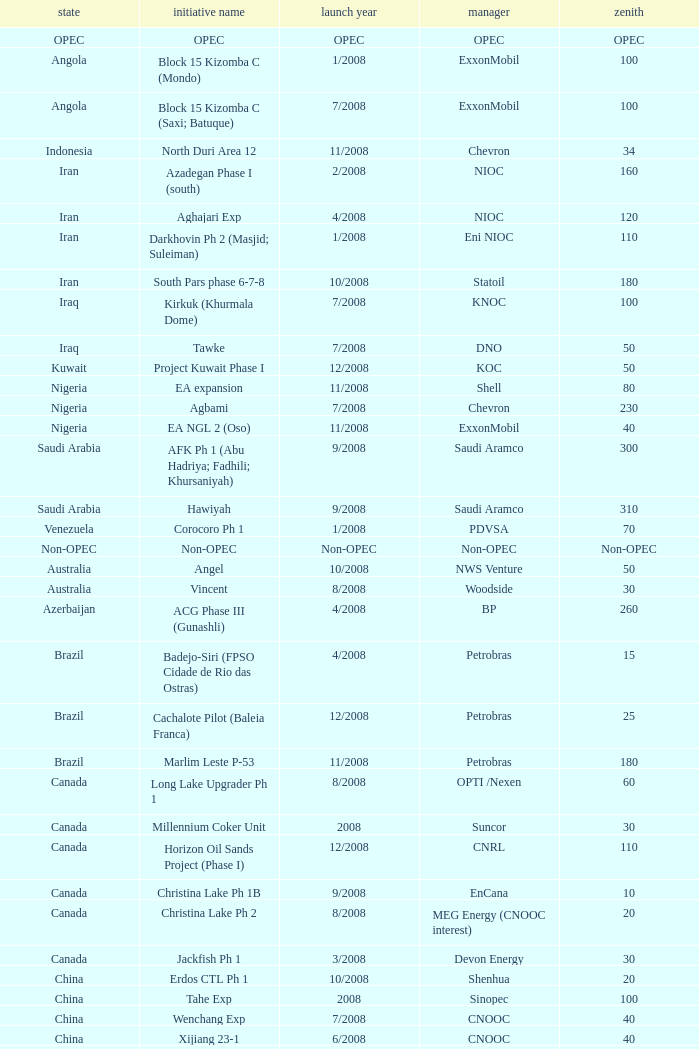What is the operator with a summit that is 55? PEMEX. I'm looking to parse the entire table for insights. Could you assist me with that? {'header': ['state', 'initiative name', 'launch year', 'manager', 'zenith'], 'rows': [['OPEC', 'OPEC', 'OPEC', 'OPEC', 'OPEC'], ['Angola', 'Block 15 Kizomba C (Mondo)', '1/2008', 'ExxonMobil', '100'], ['Angola', 'Block 15 Kizomba C (Saxi; Batuque)', '7/2008', 'ExxonMobil', '100'], ['Indonesia', 'North Duri Area 12', '11/2008', 'Chevron', '34'], ['Iran', 'Azadegan Phase I (south)', '2/2008', 'NIOC', '160'], ['Iran', 'Aghajari Exp', '4/2008', 'NIOC', '120'], ['Iran', 'Darkhovin Ph 2 (Masjid; Suleiman)', '1/2008', 'Eni NIOC', '110'], ['Iran', 'South Pars phase 6-7-8', '10/2008', 'Statoil', '180'], ['Iraq', 'Kirkuk (Khurmala Dome)', '7/2008', 'KNOC', '100'], ['Iraq', 'Tawke', '7/2008', 'DNO', '50'], ['Kuwait', 'Project Kuwait Phase I', '12/2008', 'KOC', '50'], ['Nigeria', 'EA expansion', '11/2008', 'Shell', '80'], ['Nigeria', 'Agbami', '7/2008', 'Chevron', '230'], ['Nigeria', 'EA NGL 2 (Oso)', '11/2008', 'ExxonMobil', '40'], ['Saudi Arabia', 'AFK Ph 1 (Abu Hadriya; Fadhili; Khursaniyah)', '9/2008', 'Saudi Aramco', '300'], ['Saudi Arabia', 'Hawiyah', '9/2008', 'Saudi Aramco', '310'], ['Venezuela', 'Corocoro Ph 1', '1/2008', 'PDVSA', '70'], ['Non-OPEC', 'Non-OPEC', 'Non-OPEC', 'Non-OPEC', 'Non-OPEC'], ['Australia', 'Angel', '10/2008', 'NWS Venture', '50'], ['Australia', 'Vincent', '8/2008', 'Woodside', '30'], ['Azerbaijan', 'ACG Phase III (Gunashli)', '4/2008', 'BP', '260'], ['Brazil', 'Badejo-Siri (FPSO Cidade de Rio das Ostras)', '4/2008', 'Petrobras', '15'], ['Brazil', 'Cachalote Pilot (Baleia Franca)', '12/2008', 'Petrobras', '25'], ['Brazil', 'Marlim Leste P-53', '11/2008', 'Petrobras', '180'], ['Canada', 'Long Lake Upgrader Ph 1', '8/2008', 'OPTI /Nexen', '60'], ['Canada', 'Millennium Coker Unit', '2008', 'Suncor', '30'], ['Canada', 'Horizon Oil Sands Project (Phase I)', '12/2008', 'CNRL', '110'], ['Canada', 'Christina Lake Ph 1B', '9/2008', 'EnCana', '10'], ['Canada', 'Christina Lake Ph 2', '8/2008', 'MEG Energy (CNOOC interest)', '20'], ['Canada', 'Jackfish Ph 1', '3/2008', 'Devon Energy', '30'], ['China', 'Erdos CTL Ph 1', '10/2008', 'Shenhua', '20'], ['China', 'Tahe Exp', '2008', 'Sinopec', '100'], ['China', 'Wenchang Exp', '7/2008', 'CNOOC', '40'], ['China', 'Xijiang 23-1', '6/2008', 'CNOOC', '40'], ['Congo', 'Moho Bilondo', '4/2008', 'Total', '90'], ['Egypt', 'Saqqara', '3/2008', 'BP', '40'], ['India', 'MA field (KG-D6)', '9/2008', 'Reliance', '40'], ['Kazakhstan', 'Dunga', '3/2008', 'Maersk', '150'], ['Kazakhstan', 'Komsomolskoe', '5/2008', 'Petrom', '10'], ['Mexico', '( Chicontepec ) Exp 1', '2008', 'PEMEX', '200'], ['Mexico', 'Antonio J Bermudez Exp', '5/2008', 'PEMEX', '20'], ['Mexico', 'Bellota Chinchorro Exp', '5/2008', 'PEMEX', '20'], ['Mexico', 'Ixtal Manik', '2008', 'PEMEX', '55'], ['Mexico', 'Jujo Tecominoacan Exp', '2008', 'PEMEX', '15'], ['Norway', 'Alvheim; Volund; Vilje', '6/2008', 'Marathon', '100'], ['Norway', 'Volve', '2/2008', 'StatoilHydro', '35'], ['Oman', 'Mukhaizna EOR Ph 1', '2008', 'Occidental', '40'], ['Philippines', 'Galoc', '10/2008', 'GPC', '15'], ['Russia', 'Talakan Ph 1', '10/2008', 'Surgutneftegaz', '60'], ['Russia', 'Verkhnechonsk Ph 1 (early oil)', '10/2008', 'TNK-BP Rosneft', '20'], ['Russia', 'Yuzhno-Khylchuyuskoye "YK" Ph 1', '8/2008', 'Lukoil ConocoPhillips', '75'], ['Thailand', 'Bualuang', '8/2008', 'Salamander', '10'], ['UK', 'Britannia Satellites (Callanish; Brodgar)', '7/2008', 'Conoco Phillips', '25'], ['USA', 'Blind Faith', '11/2008', 'Chevron', '45'], ['USA', 'Neptune', '7/2008', 'BHP Billiton', '25'], ['USA', 'Oooguruk', '6/2008', 'Pioneer', '15'], ['USA', 'Qannik', '7/2008', 'ConocoPhillips', '4'], ['USA', 'Thunder Horse', '6/2008', 'BP', '210'], ['USA', 'Ursa Princess Exp', '1/2008', 'Shell', '30'], ['Vietnam', 'Ca Ngu Vang (Golden Tuna)', '7/2008', 'HVJOC', '15'], ['Vietnam', 'Su Tu Vang', '10/2008', 'Cuu Long Joint', '40'], ['Vietnam', 'Song Doc', '12/2008', 'Talisman', '10']]} 